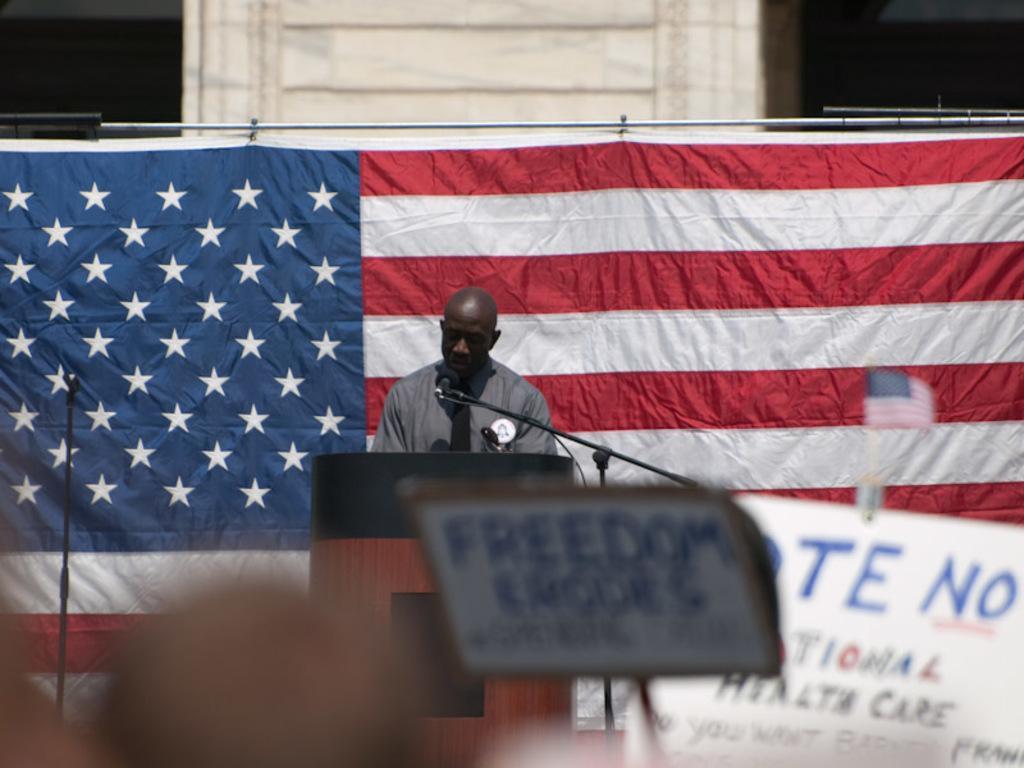Please provide a concise description of this image. In the foreground of this image, there is a head of a person and a placard. In the background, there is a flag, a board, a tiny flag and also a man standing in front of a podium and a mic along with the stand. On the left, there is another mic stand in front of the flag. In the background, it seems like a pillar. 